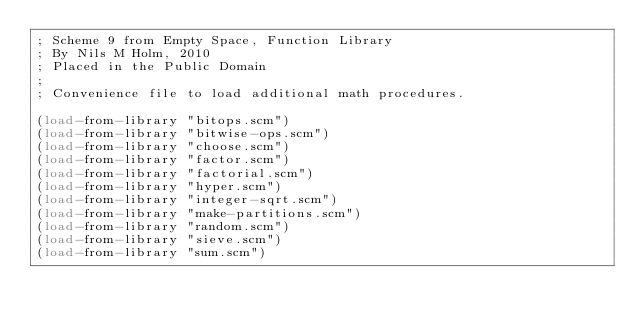Convert code to text. <code><loc_0><loc_0><loc_500><loc_500><_Scheme_>; Scheme 9 from Empty Space, Function Library
; By Nils M Holm, 2010
; Placed in the Public Domain
;
; Convenience file to load additional math procedures.

(load-from-library "bitops.scm")
(load-from-library "bitwise-ops.scm")
(load-from-library "choose.scm")
(load-from-library "factor.scm")
(load-from-library "factorial.scm")
(load-from-library "hyper.scm")
(load-from-library "integer-sqrt.scm")
(load-from-library "make-partitions.scm")
(load-from-library "random.scm")
(load-from-library "sieve.scm")
(load-from-library "sum.scm")
</code> 